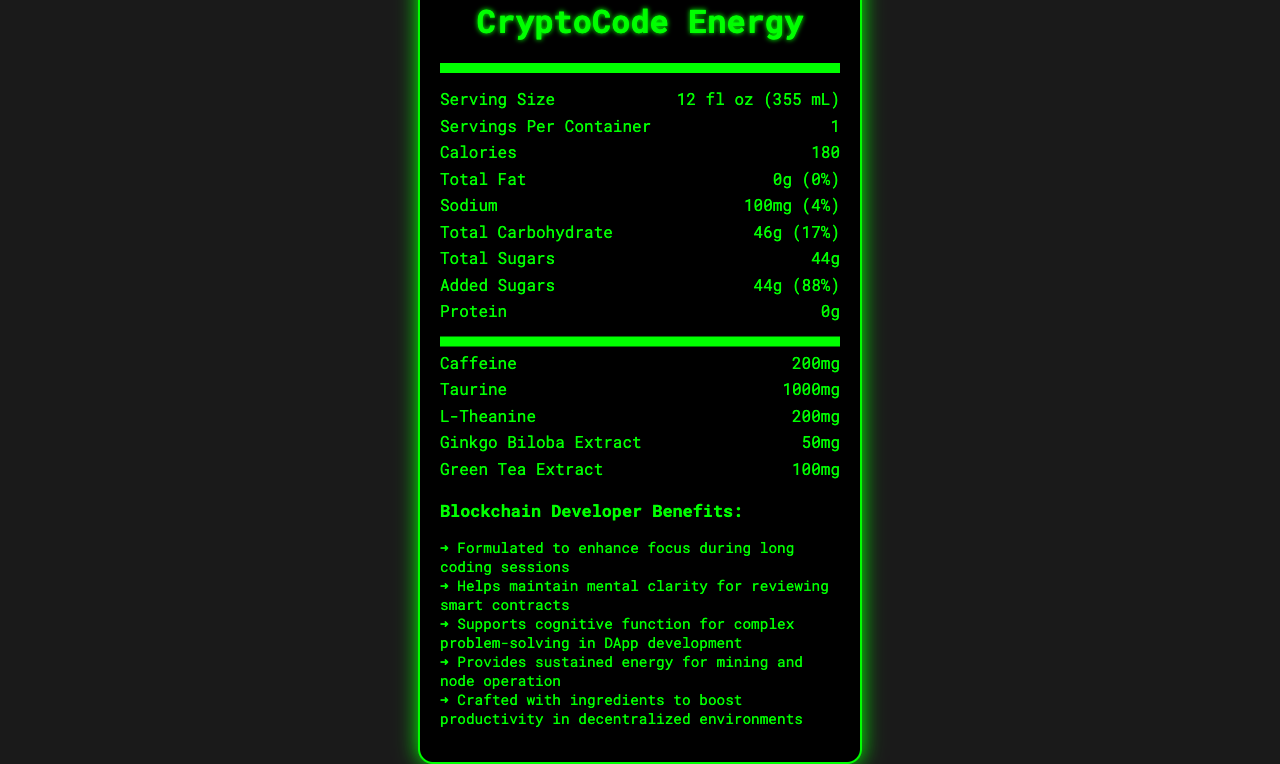how many calories are in a serving of CryptoCode Energy? The document states that a serving contains 180 calories.
Answer: 180 calories what is the serving size of CryptoCode Energy? The document lists the serving size as 12 fl oz (355 mL).
Answer: 12 fl oz (355 mL) how many grams of total sugars does CryptoCode Energy contain? The document specifies that the total sugars amount to 44 grams.
Answer: 44 grams what percentage of the daily value of Vitamin B12 does CryptoCode Energy provide? The document shows that it provides 250% of the daily value of Vitamin B12.
Answer: 250% how much caffeine is in one serving of CryptoCode Energy? The document lists the caffeine content as 200mg per serving.
Answer: 200mg which vitamin is present in the highest percentage of its daily value? 
A. Vitamin B6
B. Vitamin B12
C. Niacin
D. Pantothenic Acid Vitamin B12 is present at 250% of the daily value, which is higher than the percentages for Vitamin B6, Niacin, and Pantothenic Acid.
Answer: B. Vitamin B12 what is the total carbohydrate content in one serving of CryptoCode Energy? 
A. 44g
B. 46g
C. 50g
D. 40g The total carbohydrate content is listed as 46 grams.
Answer: B. 46g does CryptoCode Energy contain any protein? The document shows that the protein content is 0 grams.
Answer: No describe the blockchain-themed marketing points of CryptoCode Energy. The marketing section details these benefits, making it clear that the drink is specifically designed for the needs of blockchain developers.
Answer: CryptoCode Energy is formulated to enhance focus during coding sessions, maintain mental clarity for reviewing smart contracts, support cognitive function for complex problem-solving in DApp development, provide sustained energy for mining and node operation, and boost productivity in decentralized environments. who is the manufacturer of CryptoCode Energy? The document does not provide information about the manufacturer.
Answer: Not enough information 